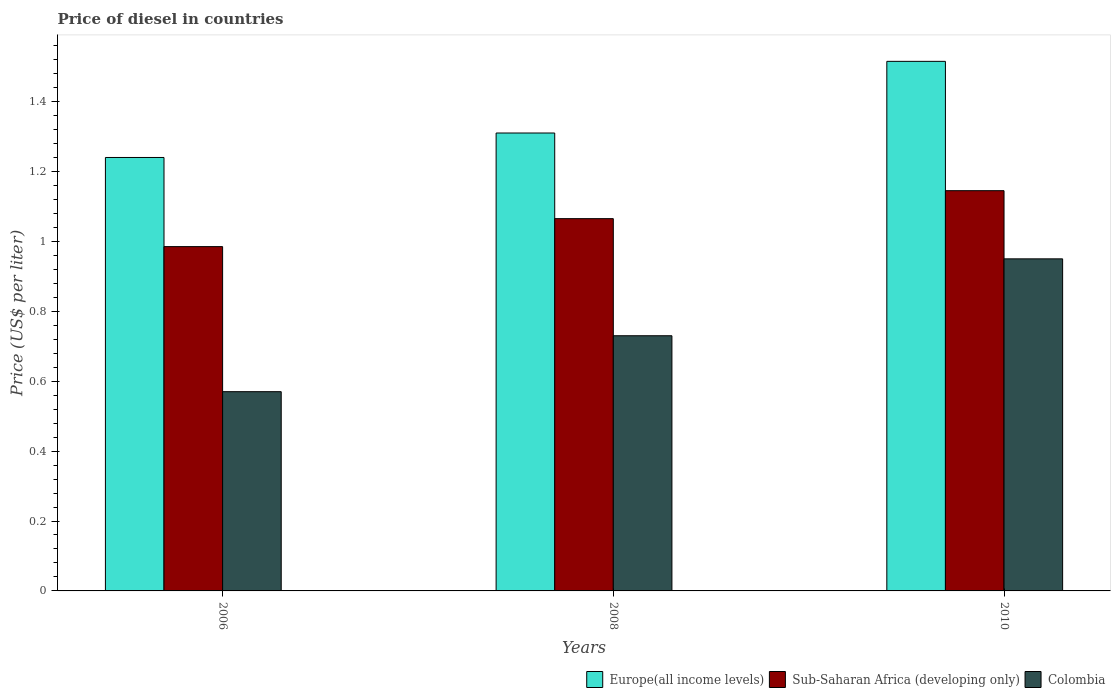How many different coloured bars are there?
Make the answer very short. 3. Are the number of bars per tick equal to the number of legend labels?
Keep it short and to the point. Yes. Are the number of bars on each tick of the X-axis equal?
Offer a very short reply. Yes. In how many cases, is the number of bars for a given year not equal to the number of legend labels?
Offer a terse response. 0. What is the price of diesel in Colombia in 2006?
Offer a very short reply. 0.57. Across all years, what is the maximum price of diesel in Sub-Saharan Africa (developing only)?
Make the answer very short. 1.15. Across all years, what is the minimum price of diesel in Europe(all income levels)?
Provide a succinct answer. 1.24. In which year was the price of diesel in Europe(all income levels) maximum?
Your answer should be compact. 2010. What is the total price of diesel in Colombia in the graph?
Your answer should be compact. 2.25. What is the difference between the price of diesel in Sub-Saharan Africa (developing only) in 2008 and that in 2010?
Provide a short and direct response. -0.08. What is the difference between the price of diesel in Europe(all income levels) in 2008 and the price of diesel in Colombia in 2006?
Ensure brevity in your answer.  0.74. What is the average price of diesel in Colombia per year?
Offer a terse response. 0.75. In the year 2006, what is the difference between the price of diesel in Sub-Saharan Africa (developing only) and price of diesel in Europe(all income levels)?
Ensure brevity in your answer.  -0.26. What is the ratio of the price of diesel in Europe(all income levels) in 2006 to that in 2010?
Your answer should be very brief. 0.82. Is the difference between the price of diesel in Sub-Saharan Africa (developing only) in 2006 and 2008 greater than the difference between the price of diesel in Europe(all income levels) in 2006 and 2008?
Provide a short and direct response. No. What is the difference between the highest and the second highest price of diesel in Sub-Saharan Africa (developing only)?
Your answer should be very brief. 0.08. What is the difference between the highest and the lowest price of diesel in Colombia?
Provide a short and direct response. 0.38. What does the 3rd bar from the right in 2006 represents?
Keep it short and to the point. Europe(all income levels). Is it the case that in every year, the sum of the price of diesel in Colombia and price of diesel in Europe(all income levels) is greater than the price of diesel in Sub-Saharan Africa (developing only)?
Your response must be concise. Yes. Are all the bars in the graph horizontal?
Keep it short and to the point. No. How many years are there in the graph?
Offer a very short reply. 3. What is the difference between two consecutive major ticks on the Y-axis?
Give a very brief answer. 0.2. Are the values on the major ticks of Y-axis written in scientific E-notation?
Your answer should be compact. No. Does the graph contain grids?
Your answer should be very brief. No. How many legend labels are there?
Offer a very short reply. 3. What is the title of the graph?
Your answer should be very brief. Price of diesel in countries. What is the label or title of the Y-axis?
Offer a very short reply. Price (US$ per liter). What is the Price (US$ per liter) in Europe(all income levels) in 2006?
Provide a succinct answer. 1.24. What is the Price (US$ per liter) in Sub-Saharan Africa (developing only) in 2006?
Make the answer very short. 0.98. What is the Price (US$ per liter) in Colombia in 2006?
Provide a short and direct response. 0.57. What is the Price (US$ per liter) in Europe(all income levels) in 2008?
Offer a very short reply. 1.31. What is the Price (US$ per liter) in Sub-Saharan Africa (developing only) in 2008?
Offer a very short reply. 1.06. What is the Price (US$ per liter) of Colombia in 2008?
Your response must be concise. 0.73. What is the Price (US$ per liter) of Europe(all income levels) in 2010?
Offer a very short reply. 1.51. What is the Price (US$ per liter) in Sub-Saharan Africa (developing only) in 2010?
Offer a terse response. 1.15. Across all years, what is the maximum Price (US$ per liter) of Europe(all income levels)?
Your answer should be very brief. 1.51. Across all years, what is the maximum Price (US$ per liter) of Sub-Saharan Africa (developing only)?
Provide a succinct answer. 1.15. Across all years, what is the minimum Price (US$ per liter) in Europe(all income levels)?
Your answer should be very brief. 1.24. Across all years, what is the minimum Price (US$ per liter) of Sub-Saharan Africa (developing only)?
Offer a very short reply. 0.98. Across all years, what is the minimum Price (US$ per liter) in Colombia?
Keep it short and to the point. 0.57. What is the total Price (US$ per liter) in Europe(all income levels) in the graph?
Make the answer very short. 4.07. What is the total Price (US$ per liter) of Sub-Saharan Africa (developing only) in the graph?
Keep it short and to the point. 3.19. What is the total Price (US$ per liter) in Colombia in the graph?
Give a very brief answer. 2.25. What is the difference between the Price (US$ per liter) in Europe(all income levels) in 2006 and that in 2008?
Your response must be concise. -0.07. What is the difference between the Price (US$ per liter) of Sub-Saharan Africa (developing only) in 2006 and that in 2008?
Ensure brevity in your answer.  -0.08. What is the difference between the Price (US$ per liter) of Colombia in 2006 and that in 2008?
Give a very brief answer. -0.16. What is the difference between the Price (US$ per liter) of Europe(all income levels) in 2006 and that in 2010?
Your answer should be compact. -0.28. What is the difference between the Price (US$ per liter) in Sub-Saharan Africa (developing only) in 2006 and that in 2010?
Provide a succinct answer. -0.16. What is the difference between the Price (US$ per liter) in Colombia in 2006 and that in 2010?
Provide a short and direct response. -0.38. What is the difference between the Price (US$ per liter) in Europe(all income levels) in 2008 and that in 2010?
Make the answer very short. -0.2. What is the difference between the Price (US$ per liter) of Sub-Saharan Africa (developing only) in 2008 and that in 2010?
Your response must be concise. -0.08. What is the difference between the Price (US$ per liter) of Colombia in 2008 and that in 2010?
Make the answer very short. -0.22. What is the difference between the Price (US$ per liter) in Europe(all income levels) in 2006 and the Price (US$ per liter) in Sub-Saharan Africa (developing only) in 2008?
Keep it short and to the point. 0.17. What is the difference between the Price (US$ per liter) of Europe(all income levels) in 2006 and the Price (US$ per liter) of Colombia in 2008?
Give a very brief answer. 0.51. What is the difference between the Price (US$ per liter) of Sub-Saharan Africa (developing only) in 2006 and the Price (US$ per liter) of Colombia in 2008?
Your response must be concise. 0.26. What is the difference between the Price (US$ per liter) of Europe(all income levels) in 2006 and the Price (US$ per liter) of Sub-Saharan Africa (developing only) in 2010?
Give a very brief answer. 0.1. What is the difference between the Price (US$ per liter) of Europe(all income levels) in 2006 and the Price (US$ per liter) of Colombia in 2010?
Your response must be concise. 0.29. What is the difference between the Price (US$ per liter) of Sub-Saharan Africa (developing only) in 2006 and the Price (US$ per liter) of Colombia in 2010?
Offer a very short reply. 0.04. What is the difference between the Price (US$ per liter) of Europe(all income levels) in 2008 and the Price (US$ per liter) of Sub-Saharan Africa (developing only) in 2010?
Ensure brevity in your answer.  0.17. What is the difference between the Price (US$ per liter) in Europe(all income levels) in 2008 and the Price (US$ per liter) in Colombia in 2010?
Give a very brief answer. 0.36. What is the difference between the Price (US$ per liter) of Sub-Saharan Africa (developing only) in 2008 and the Price (US$ per liter) of Colombia in 2010?
Offer a very short reply. 0.12. What is the average Price (US$ per liter) of Europe(all income levels) per year?
Offer a very short reply. 1.35. What is the average Price (US$ per liter) of Sub-Saharan Africa (developing only) per year?
Give a very brief answer. 1.06. What is the average Price (US$ per liter) of Colombia per year?
Your response must be concise. 0.75. In the year 2006, what is the difference between the Price (US$ per liter) in Europe(all income levels) and Price (US$ per liter) in Sub-Saharan Africa (developing only)?
Your answer should be very brief. 0.26. In the year 2006, what is the difference between the Price (US$ per liter) of Europe(all income levels) and Price (US$ per liter) of Colombia?
Make the answer very short. 0.67. In the year 2006, what is the difference between the Price (US$ per liter) in Sub-Saharan Africa (developing only) and Price (US$ per liter) in Colombia?
Keep it short and to the point. 0.41. In the year 2008, what is the difference between the Price (US$ per liter) in Europe(all income levels) and Price (US$ per liter) in Sub-Saharan Africa (developing only)?
Keep it short and to the point. 0.24. In the year 2008, what is the difference between the Price (US$ per liter) of Europe(all income levels) and Price (US$ per liter) of Colombia?
Keep it short and to the point. 0.58. In the year 2008, what is the difference between the Price (US$ per liter) in Sub-Saharan Africa (developing only) and Price (US$ per liter) in Colombia?
Make the answer very short. 0.34. In the year 2010, what is the difference between the Price (US$ per liter) of Europe(all income levels) and Price (US$ per liter) of Sub-Saharan Africa (developing only)?
Keep it short and to the point. 0.37. In the year 2010, what is the difference between the Price (US$ per liter) in Europe(all income levels) and Price (US$ per liter) in Colombia?
Make the answer very short. 0.56. In the year 2010, what is the difference between the Price (US$ per liter) of Sub-Saharan Africa (developing only) and Price (US$ per liter) of Colombia?
Keep it short and to the point. 0.2. What is the ratio of the Price (US$ per liter) in Europe(all income levels) in 2006 to that in 2008?
Offer a terse response. 0.95. What is the ratio of the Price (US$ per liter) of Sub-Saharan Africa (developing only) in 2006 to that in 2008?
Your response must be concise. 0.92. What is the ratio of the Price (US$ per liter) in Colombia in 2006 to that in 2008?
Provide a succinct answer. 0.78. What is the ratio of the Price (US$ per liter) of Europe(all income levels) in 2006 to that in 2010?
Your answer should be compact. 0.82. What is the ratio of the Price (US$ per liter) in Sub-Saharan Africa (developing only) in 2006 to that in 2010?
Keep it short and to the point. 0.86. What is the ratio of the Price (US$ per liter) in Europe(all income levels) in 2008 to that in 2010?
Provide a succinct answer. 0.86. What is the ratio of the Price (US$ per liter) in Sub-Saharan Africa (developing only) in 2008 to that in 2010?
Provide a short and direct response. 0.93. What is the ratio of the Price (US$ per liter) in Colombia in 2008 to that in 2010?
Provide a short and direct response. 0.77. What is the difference between the highest and the second highest Price (US$ per liter) in Europe(all income levels)?
Provide a succinct answer. 0.2. What is the difference between the highest and the second highest Price (US$ per liter) in Sub-Saharan Africa (developing only)?
Ensure brevity in your answer.  0.08. What is the difference between the highest and the second highest Price (US$ per liter) in Colombia?
Make the answer very short. 0.22. What is the difference between the highest and the lowest Price (US$ per liter) in Europe(all income levels)?
Offer a very short reply. 0.28. What is the difference between the highest and the lowest Price (US$ per liter) of Sub-Saharan Africa (developing only)?
Your answer should be compact. 0.16. What is the difference between the highest and the lowest Price (US$ per liter) in Colombia?
Provide a short and direct response. 0.38. 